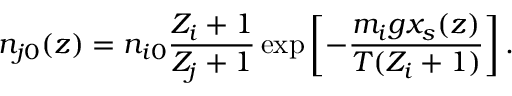<formula> <loc_0><loc_0><loc_500><loc_500>n _ { j 0 } ( z ) = n _ { i 0 } { \frac { Z _ { i } + 1 } { Z _ { j } + 1 } } \exp \left [ - { \frac { m _ { i } g x _ { s } ( z ) } { T ( Z _ { i } + 1 ) } } \right ] .</formula> 